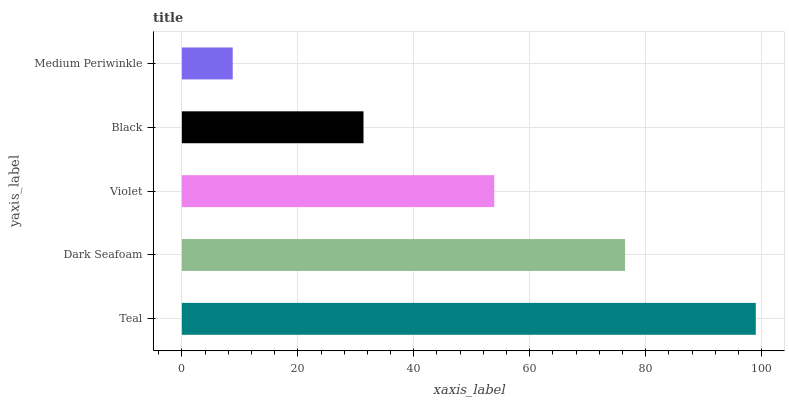Is Medium Periwinkle the minimum?
Answer yes or no. Yes. Is Teal the maximum?
Answer yes or no. Yes. Is Dark Seafoam the minimum?
Answer yes or no. No. Is Dark Seafoam the maximum?
Answer yes or no. No. Is Teal greater than Dark Seafoam?
Answer yes or no. Yes. Is Dark Seafoam less than Teal?
Answer yes or no. Yes. Is Dark Seafoam greater than Teal?
Answer yes or no. No. Is Teal less than Dark Seafoam?
Answer yes or no. No. Is Violet the high median?
Answer yes or no. Yes. Is Violet the low median?
Answer yes or no. Yes. Is Dark Seafoam the high median?
Answer yes or no. No. Is Medium Periwinkle the low median?
Answer yes or no. No. 